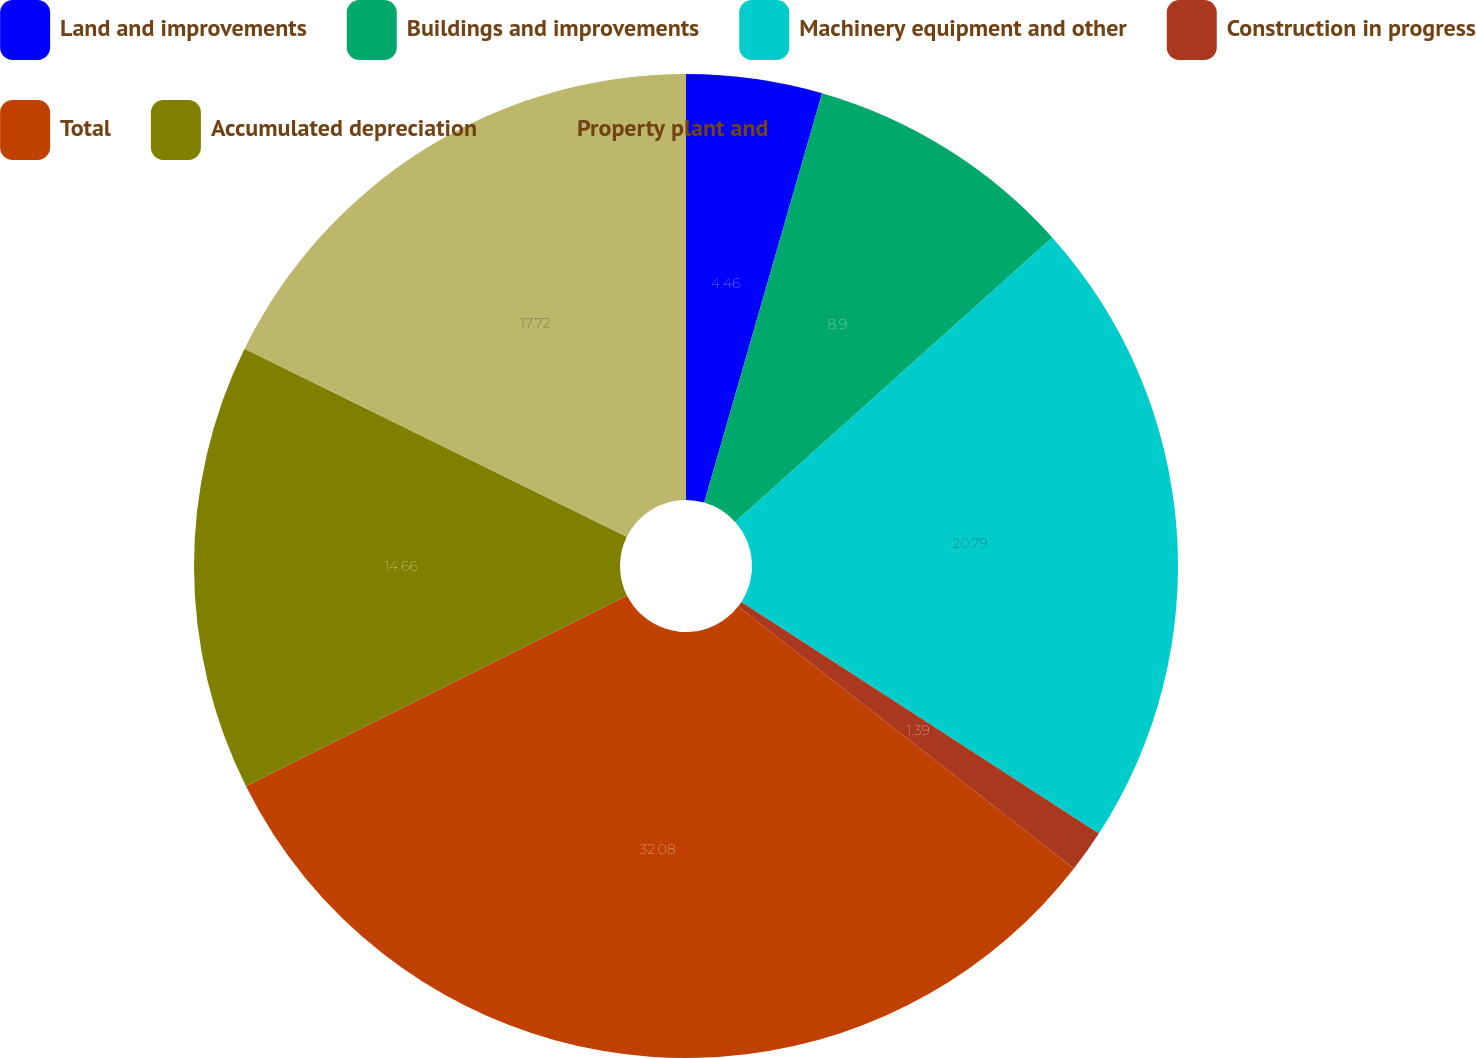Convert chart. <chart><loc_0><loc_0><loc_500><loc_500><pie_chart><fcel>Land and improvements<fcel>Buildings and improvements<fcel>Machinery equipment and other<fcel>Construction in progress<fcel>Total<fcel>Accumulated depreciation<fcel>Property plant and<nl><fcel>4.46%<fcel>8.9%<fcel>20.79%<fcel>1.39%<fcel>32.07%<fcel>14.66%<fcel>17.72%<nl></chart> 